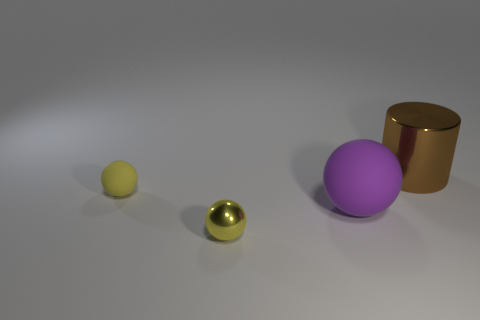Do the large shiny thing and the tiny thing in front of the big purple sphere have the same color?
Ensure brevity in your answer.  No. What is the color of the other matte thing that is the same shape as the large purple thing?
Make the answer very short. Yellow. Are the big cylinder and the big thing in front of the cylinder made of the same material?
Your answer should be compact. No. The tiny matte thing has what color?
Your response must be concise. Yellow. What color is the shiny object that is in front of the tiny yellow thing that is behind the tiny yellow sphere in front of the purple rubber ball?
Your response must be concise. Yellow. Do the tiny yellow metallic thing and the yellow thing behind the purple rubber object have the same shape?
Give a very brief answer. Yes. There is a thing that is both behind the purple ball and on the left side of the large purple ball; what color is it?
Your answer should be very brief. Yellow. Are there any big purple rubber objects that have the same shape as the tiny shiny object?
Provide a short and direct response. Yes. Do the large cylinder and the small matte thing have the same color?
Your answer should be very brief. No. There is a big object in front of the large brown metal object; are there any brown shiny cylinders behind it?
Your answer should be very brief. Yes. 